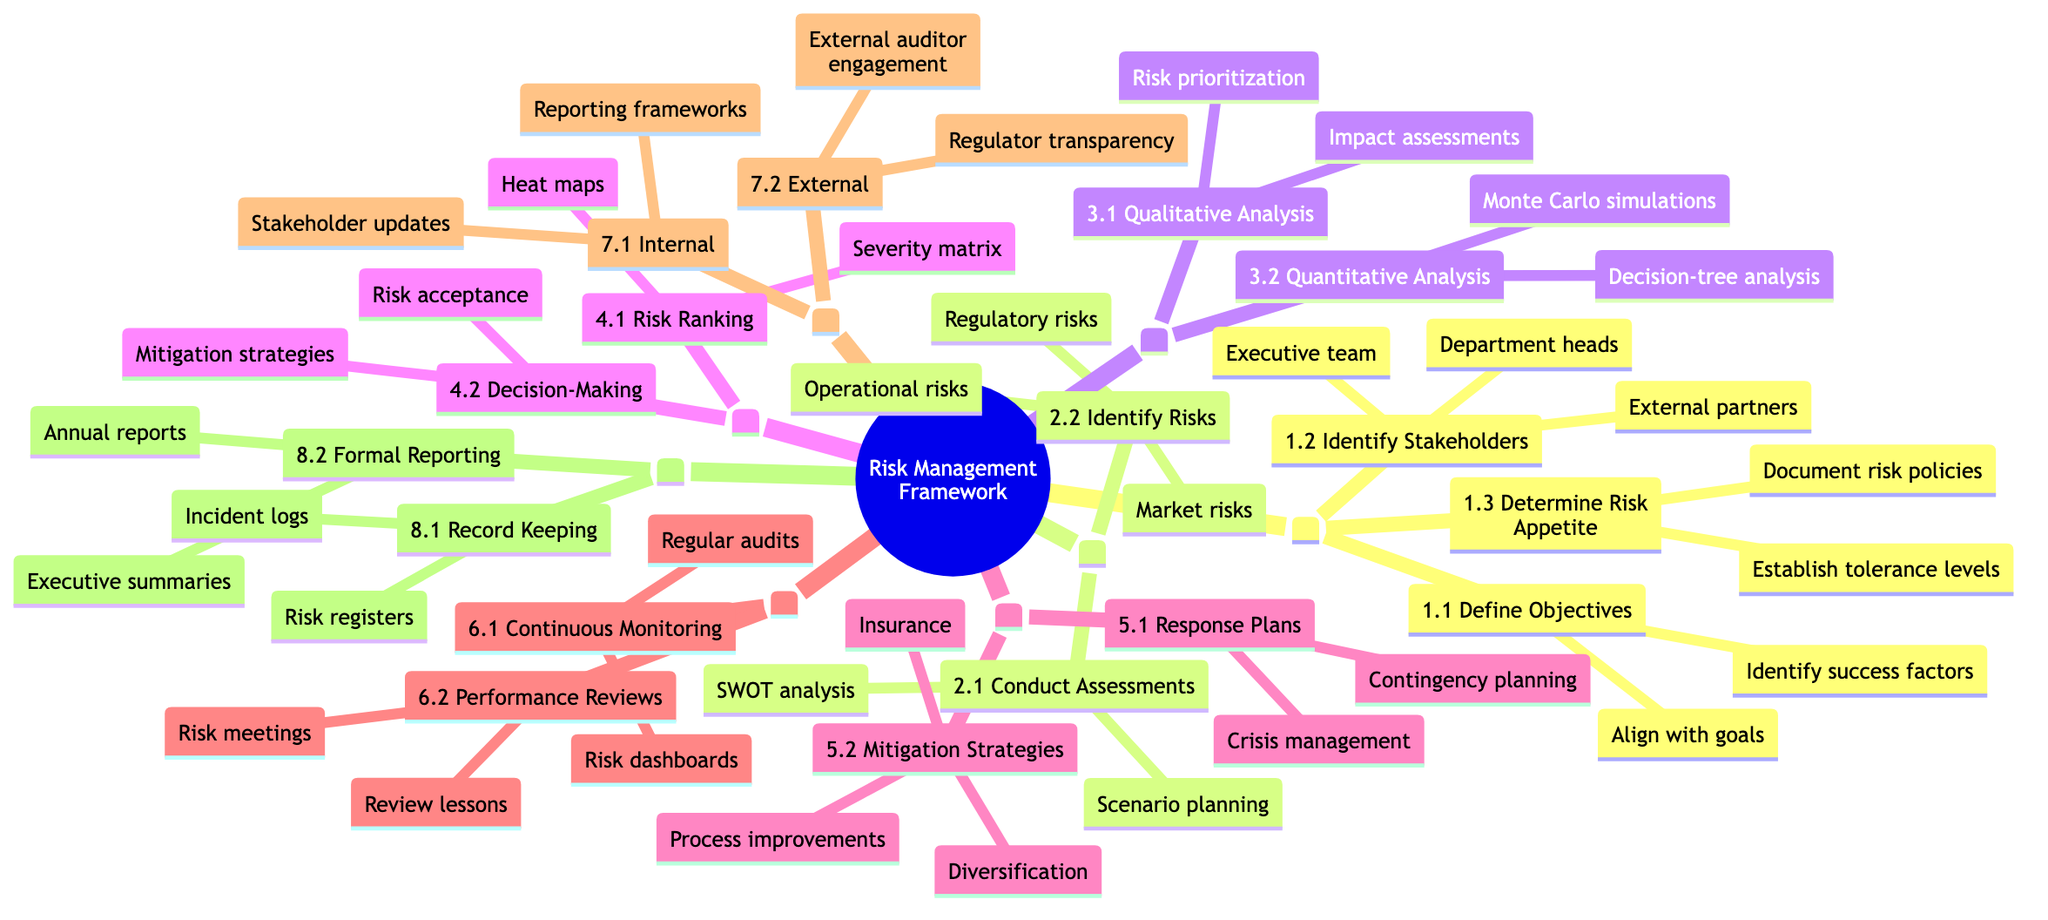What are the three main components under "Establish Context"? According to the diagram, the three main components under "Establish Context" are "Define Objectives," "Identify Stakeholders," and "Determine Risk Appetite."
Answer: Define Objectives, Identify Stakeholders, Determine Risk Appetite How many strategies are listed under "Risk Treatment"? The "Risk Treatment" section has two main strategies: "Develop Response Plans" and "Implement Mitigation Strategies." Therefore, there are 2 strategies listed.
Answer: 2 Which type of analysis is used in "Risk Evaluation" for prioritizing risks? In "Risk Evaluation," the "Risk Ranking" utilizes the "Severity and frequency matrix" and "Heat maps" for prioritizing risks. Therefore, these are the types of analysis used.
Answer: Severity and frequency matrix, Heat maps What is the focus of the "Monitoring and Review" step? The "Monitoring and Review" step focuses on "Continuous Monitoring" and "Performance Reviews," encompassing both ongoing oversight and assessing risk management effectiveness.
Answer: Continuous Monitoring, Performance Reviews How many types of communication are specified in "Communication and Consultation"? The diagram outlines two types of communication in "Communication and Consultation": "Internal Communication" and "External Communication." Therefore, there are 2 types specified.
Answer: 2 What are the two forms of documentation noted under "Documentation and Reporting"? Under "Documentation and Reporting," the two forms noted are "Record Keeping" and "Formal Reporting." This includes keeping records of risks and reporting on them formally.
Answer: Record Keeping, Formal Reporting Which specific risk analysis method is included in "Quantitative Analysis"? "Quantitative Analysis" includes the method "Monte Carlo simulations," which is listed explicitly in the diagram as a type of analysis used for understanding risk quantitatively.
Answer: Monte Carlo simulations How can stakeholders be informed internally according to the diagram? Stakeholders can be informed internally through "Regular updates to stakeholders" and "Risk reporting frameworks," which are both integral parts of internal communication within the framework.
Answer: Regular updates to stakeholders, Risk reporting frameworks 